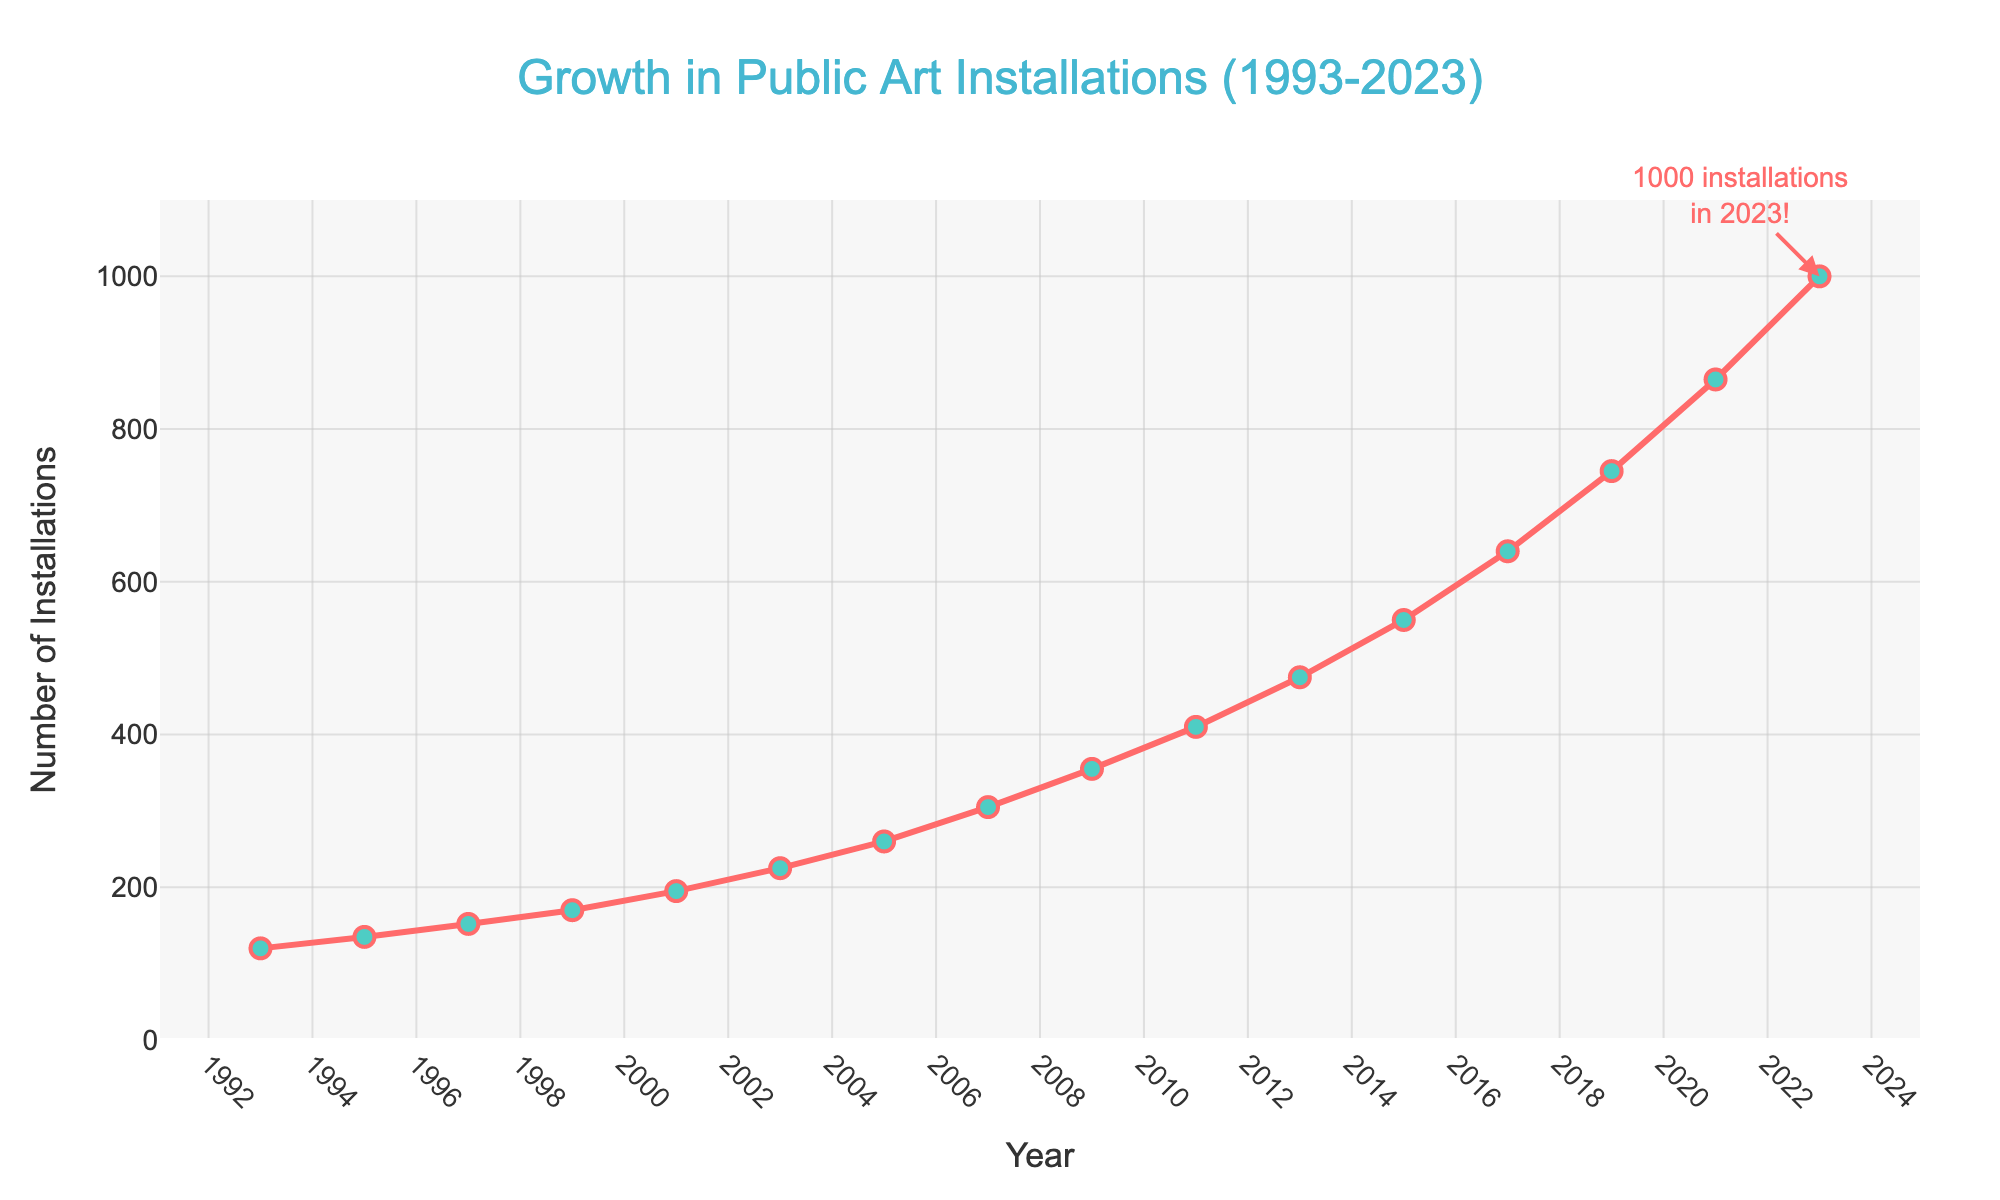What's the total number of public art installations added between 1993 and 2023? To find the total number of installations added between 1993 and 2023, subtract the number of installations in 1993 from the number of installations in 2023: 1000 - 120 = 880
Answer: 880 How many public art installations were there in 2015 compared to 2005? To compare the number of installations in 2015 and 2005, look at the respective values: 550 in 2015 and 260 in 2005. The difference is 550 - 260 = 290
Answer: 290 In which year did the number of public art installations first exceed 500? Look for the year when the number of installations first becomes greater than 500. In 2013, the number of installations is 475, and in 2015 it is 550. Therefore, the year when it first exceeds 500 is 2015
Answer: 2015 What is the average number of installations added every 5 years from 1993 to 2023? From 1993 to 2023 is a span of 30 years, divided into six 5-year periods. Calculate the differences in each 5-year interval and then find the average. The differences are: (135-120), (170-135), (225-195), (305-260), (475-355), (740-640). Summing these gives: 15 + 35 + 30 + 45 + 120 = 245. Average over 5 periods: 275 / 5 = 49
Answer: 49 Which year saw the largest increase in the number of public art installations? Find the year-to-year increases and identify the largest. The largest increments are: (152-135)=17 (1997); (170-152)=18 (1999); (225-195)=30 (2003); (475-410)=65 (2013); (475-550)=75 (2015). The largest increase occurred in 2015 by 75
Answer: 2015 Is the growth in public art installations more rapid after 2003 compared to before 2003? Between 1993 to 2003 (10 years), installations increased from 120 to 225, which is an average of (225-120)/10 = 10.5 per year. Between 2003 to 2023 (20 years), installations increased from 225 to 1000, averaging (1000-225)/20 = 38.75 per year. Yes, growth is more rapid after 2003
Answer: Yes Describe the trend in the number of public art installations over the last 6 years. To describe the trend, check data points from 2017 to 2023. There were 740 installations in 2017 and 1000 in 2023, showing a consistent increasing trend. The overall increase from 2017 to 2023 is 1000 - 640 = 260, and the trend is upward
Answer: Upward What visual features in the graph indicate major increases in public art installations? The markers and lines on the graph sharply increase in the later years, especially after 2003, indicating major increases. The line's slope becomes steeper, showing more rapid growth
Answer: Steeper line slopes 